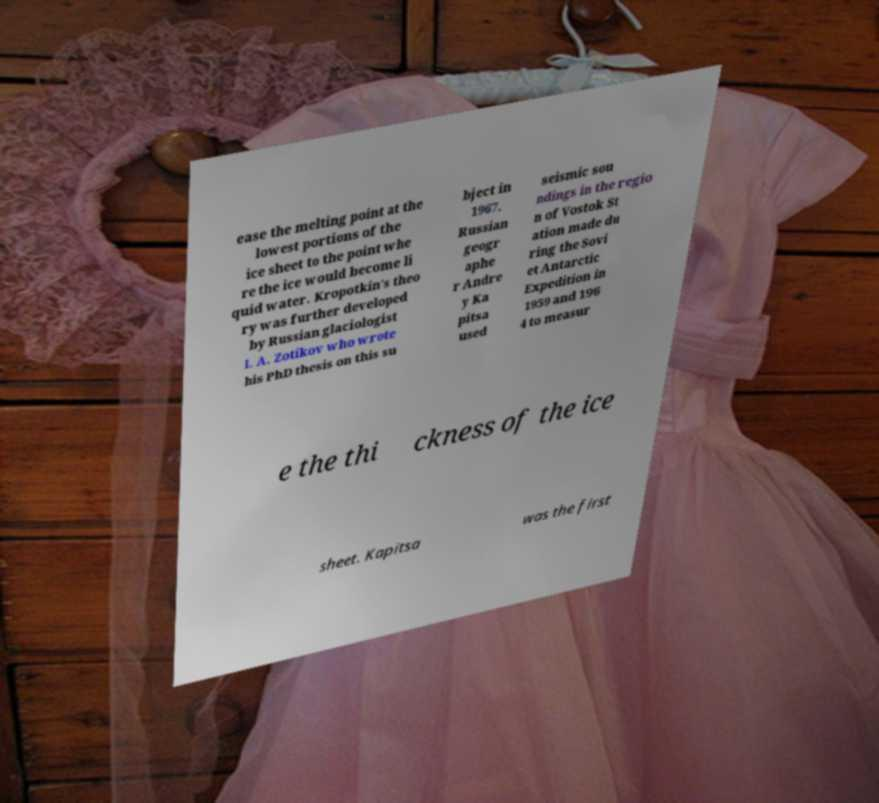Can you accurately transcribe the text from the provided image for me? ease the melting point at the lowest portions of the ice sheet to the point whe re the ice would become li quid water. Kropotkin's theo ry was further developed by Russian glaciologist I. A. Zotikov who wrote his PhD thesis on this su bject in 1967. Russian geogr aphe r Andre y Ka pitsa used seismic sou ndings in the regio n of Vostok St ation made du ring the Sovi et Antarctic Expedition in 1959 and 196 4 to measur e the thi ckness of the ice sheet. Kapitsa was the first 